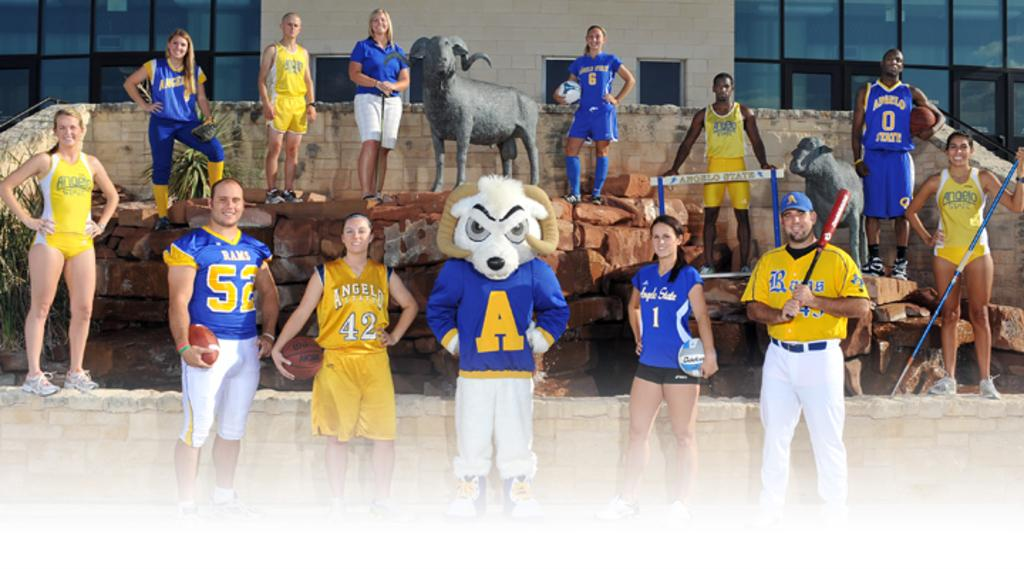<image>
Summarize the visual content of the image. Several athletes from Angelo State pose with their sports equipment. 